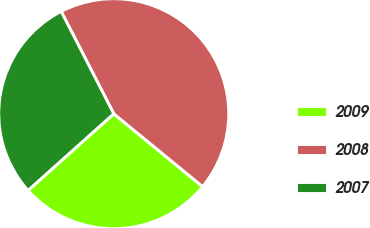Convert chart to OTSL. <chart><loc_0><loc_0><loc_500><loc_500><pie_chart><fcel>2009<fcel>2008<fcel>2007<nl><fcel>27.45%<fcel>43.49%<fcel>29.06%<nl></chart> 